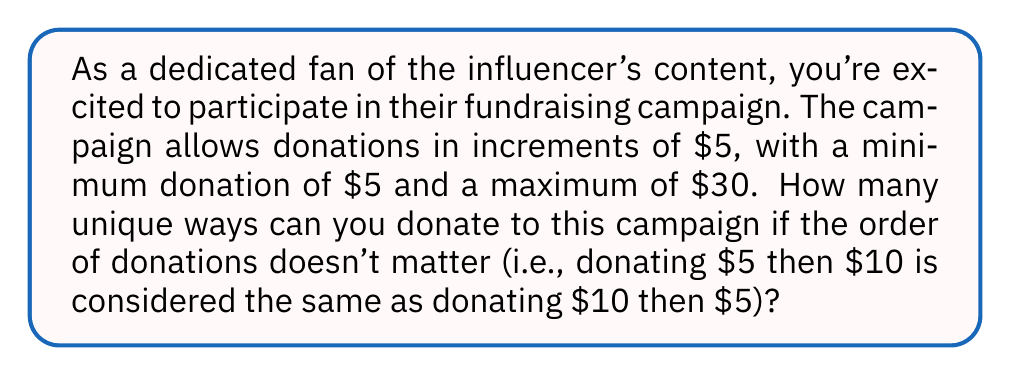Can you solve this math problem? Let's approach this step-by-step:

1) First, we need to identify the possible donation amounts:
   $5, $10, $15, $20, $25, $30

2) This problem is equivalent to finding the number of ways to write 30 as a sum of multiples of 5, where the order doesn't matter. In number theory, this is known as a partition problem.

3) We can use generating functions to solve this. Let's define our generating function:

   $$F(x) = (1 + x^5 + x^{10} + x^{15} + x^{20} + x^{25} + x^{30})$$

   Each term represents a possible donation amount, and the coefficient of $x^n$ in the expanded function will represent the number of ways to donate $n.

4) We're interested in the coefficient of $x^{30}$ in this expansion.

5) To calculate this, we can use the following formula:

   $$\text{coefficient of } x^{30} = \frac{1}{30!} \cdot \frac{d^{30}F}{dx^{30}}(0)$$

6) Calculating this directly would be complex, but we can simplify by noting that this is equivalent to the number of partitions of 6 (as we're partitioning 30 into multiples of 5).

7) The partitions of 6 are:
   6
   5 + 1
   4 + 2
   4 + 1 + 1
   3 + 3
   3 + 2 + 1
   2 + 2 + 2
   2 + 2 + 1 + 1
   2 + 1 + 1 + 1 + 1
   1 + 1 + 1 + 1 + 1 + 1

8) Counting these partitions, we find there are 11 of them.

Therefore, there are 11 unique ways to donate to the fundraising campaign.
Answer: 11 